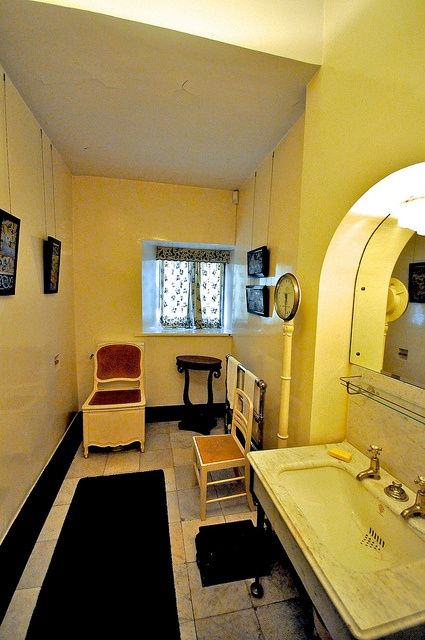Describe the objects in this image and their specific colors. I can see sink in gray, tan, khaki, and olive tones, chair in gray, maroon, orange, and tan tones, chair in gray, olive, black, and maroon tones, and clock in gray, tan, and olive tones in this image. 